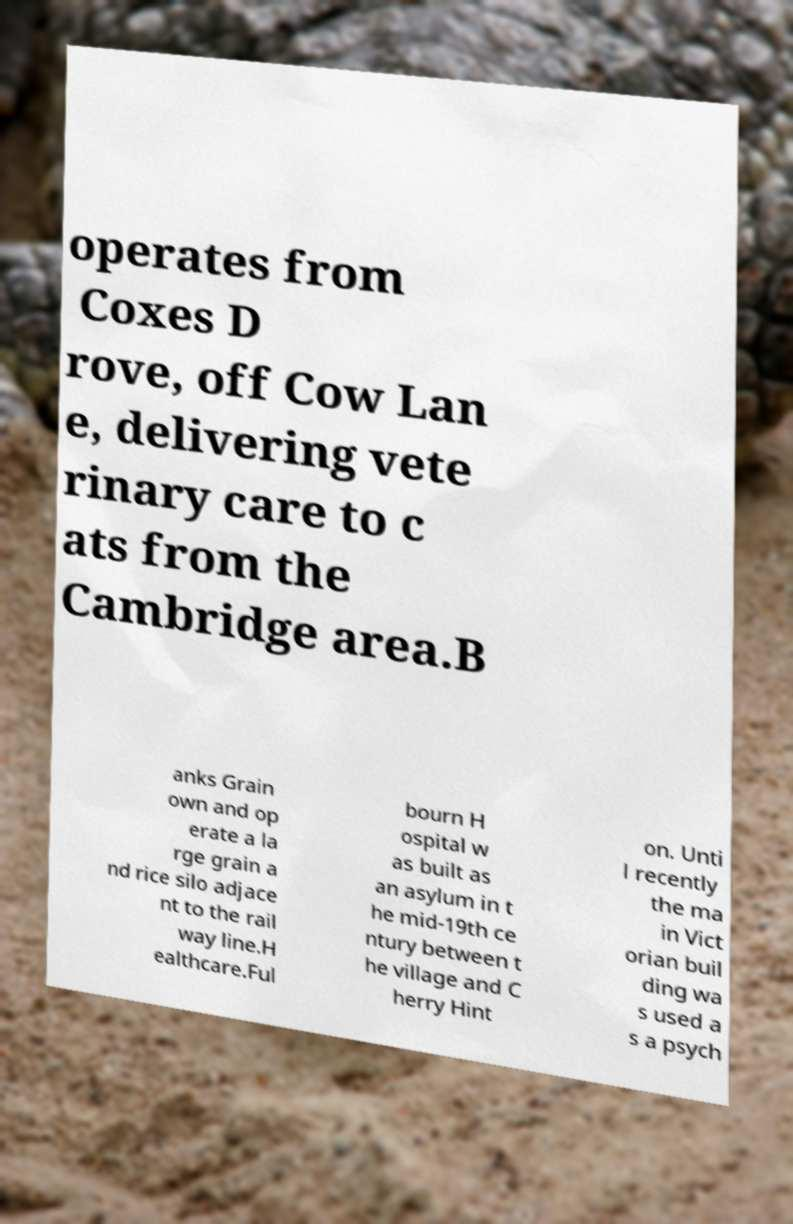Could you assist in decoding the text presented in this image and type it out clearly? operates from Coxes D rove, off Cow Lan e, delivering vete rinary care to c ats from the Cambridge area.B anks Grain own and op erate a la rge grain a nd rice silo adjace nt to the rail way line.H ealthcare.Ful bourn H ospital w as built as an asylum in t he mid-19th ce ntury between t he village and C herry Hint on. Unti l recently the ma in Vict orian buil ding wa s used a s a psych 